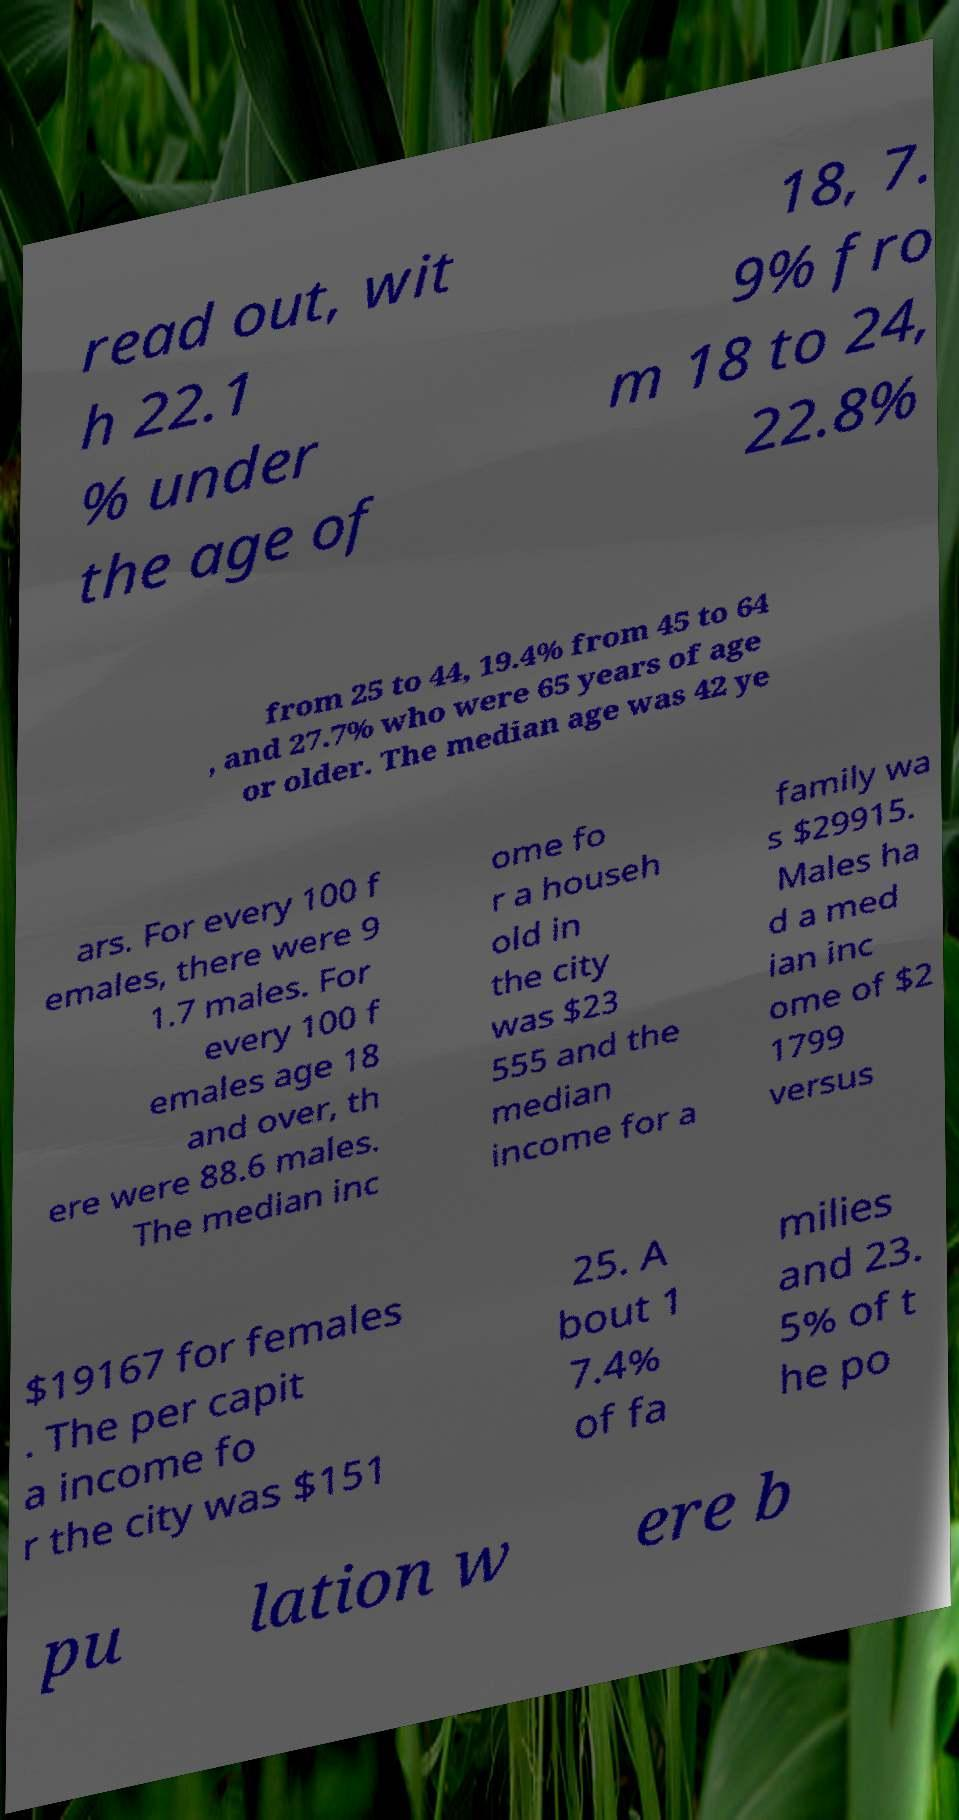Can you read and provide the text displayed in the image?This photo seems to have some interesting text. Can you extract and type it out for me? read out, wit h 22.1 % under the age of 18, 7. 9% fro m 18 to 24, 22.8% from 25 to 44, 19.4% from 45 to 64 , and 27.7% who were 65 years of age or older. The median age was 42 ye ars. For every 100 f emales, there were 9 1.7 males. For every 100 f emales age 18 and over, th ere were 88.6 males. The median inc ome fo r a househ old in the city was $23 555 and the median income for a family wa s $29915. Males ha d a med ian inc ome of $2 1799 versus $19167 for females . The per capit a income fo r the city was $151 25. A bout 1 7.4% of fa milies and 23. 5% of t he po pu lation w ere b 